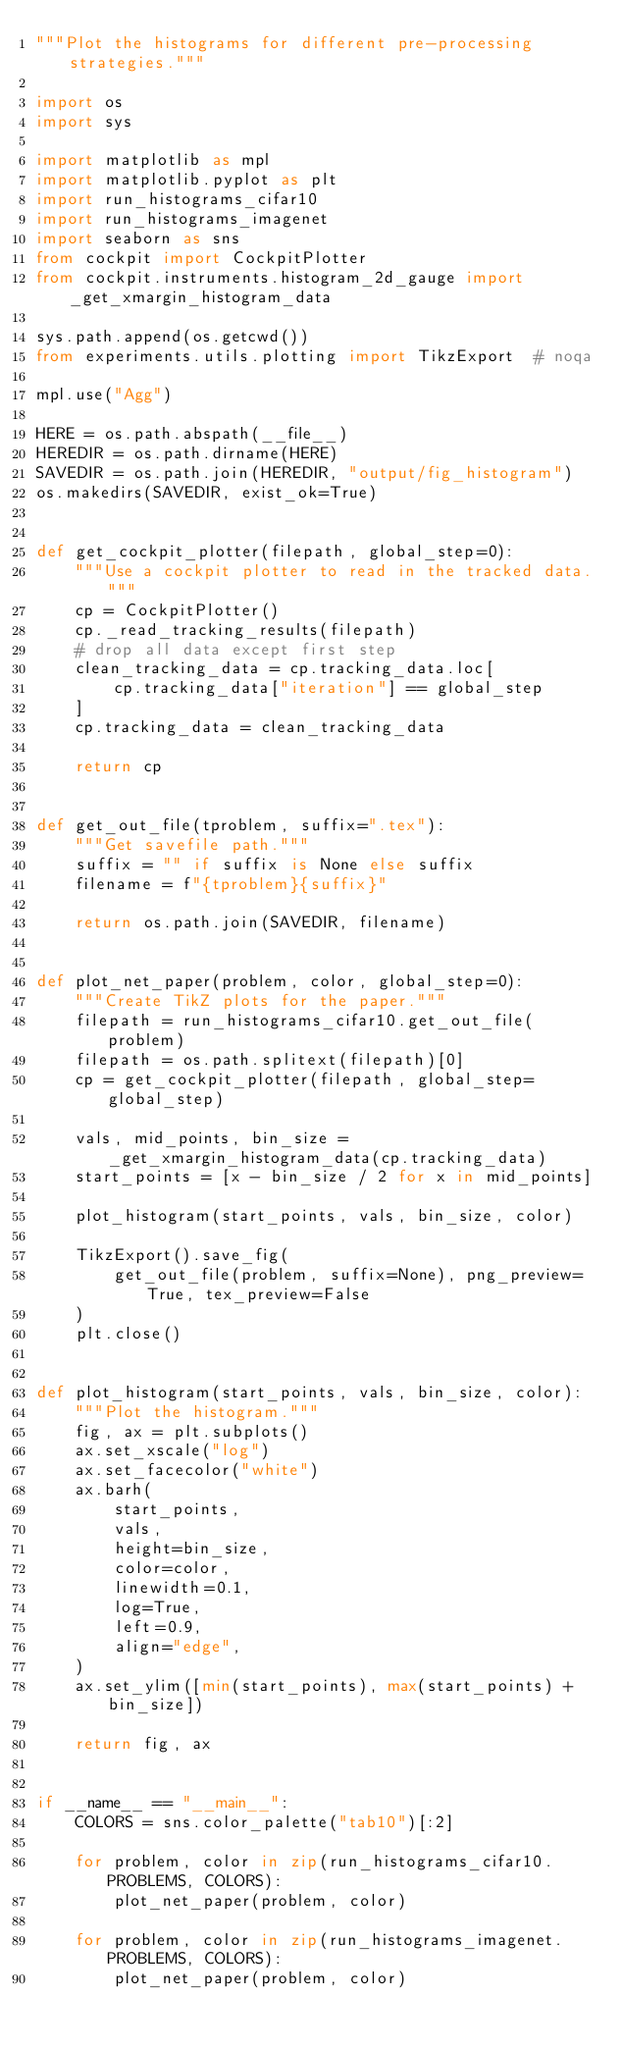Convert code to text. <code><loc_0><loc_0><loc_500><loc_500><_Python_>"""Plot the histograms for different pre-processing strategies."""

import os
import sys

import matplotlib as mpl
import matplotlib.pyplot as plt
import run_histograms_cifar10
import run_histograms_imagenet
import seaborn as sns
from cockpit import CockpitPlotter
from cockpit.instruments.histogram_2d_gauge import _get_xmargin_histogram_data

sys.path.append(os.getcwd())
from experiments.utils.plotting import TikzExport  # noqa

mpl.use("Agg")

HERE = os.path.abspath(__file__)
HEREDIR = os.path.dirname(HERE)
SAVEDIR = os.path.join(HEREDIR, "output/fig_histogram")
os.makedirs(SAVEDIR, exist_ok=True)


def get_cockpit_plotter(filepath, global_step=0):
    """Use a cockpit plotter to read in the tracked data."""
    cp = CockpitPlotter()
    cp._read_tracking_results(filepath)
    # drop all data except first step
    clean_tracking_data = cp.tracking_data.loc[
        cp.tracking_data["iteration"] == global_step
    ]
    cp.tracking_data = clean_tracking_data

    return cp


def get_out_file(tproblem, suffix=".tex"):
    """Get savefile path."""
    suffix = "" if suffix is None else suffix
    filename = f"{tproblem}{suffix}"

    return os.path.join(SAVEDIR, filename)


def plot_net_paper(problem, color, global_step=0):
    """Create TikZ plots for the paper."""
    filepath = run_histograms_cifar10.get_out_file(problem)
    filepath = os.path.splitext(filepath)[0]
    cp = get_cockpit_plotter(filepath, global_step=global_step)

    vals, mid_points, bin_size = _get_xmargin_histogram_data(cp.tracking_data)
    start_points = [x - bin_size / 2 for x in mid_points]

    plot_histogram(start_points, vals, bin_size, color)

    TikzExport().save_fig(
        get_out_file(problem, suffix=None), png_preview=True, tex_preview=False
    )
    plt.close()


def plot_histogram(start_points, vals, bin_size, color):
    """Plot the histogram."""
    fig, ax = plt.subplots()
    ax.set_xscale("log")
    ax.set_facecolor("white")
    ax.barh(
        start_points,
        vals,
        height=bin_size,
        color=color,
        linewidth=0.1,
        log=True,
        left=0.9,
        align="edge",
    )
    ax.set_ylim([min(start_points), max(start_points) + bin_size])

    return fig, ax


if __name__ == "__main__":
    COLORS = sns.color_palette("tab10")[:2]

    for problem, color in zip(run_histograms_cifar10.PROBLEMS, COLORS):
        plot_net_paper(problem, color)

    for problem, color in zip(run_histograms_imagenet.PROBLEMS, COLORS):
        plot_net_paper(problem, color)
</code> 